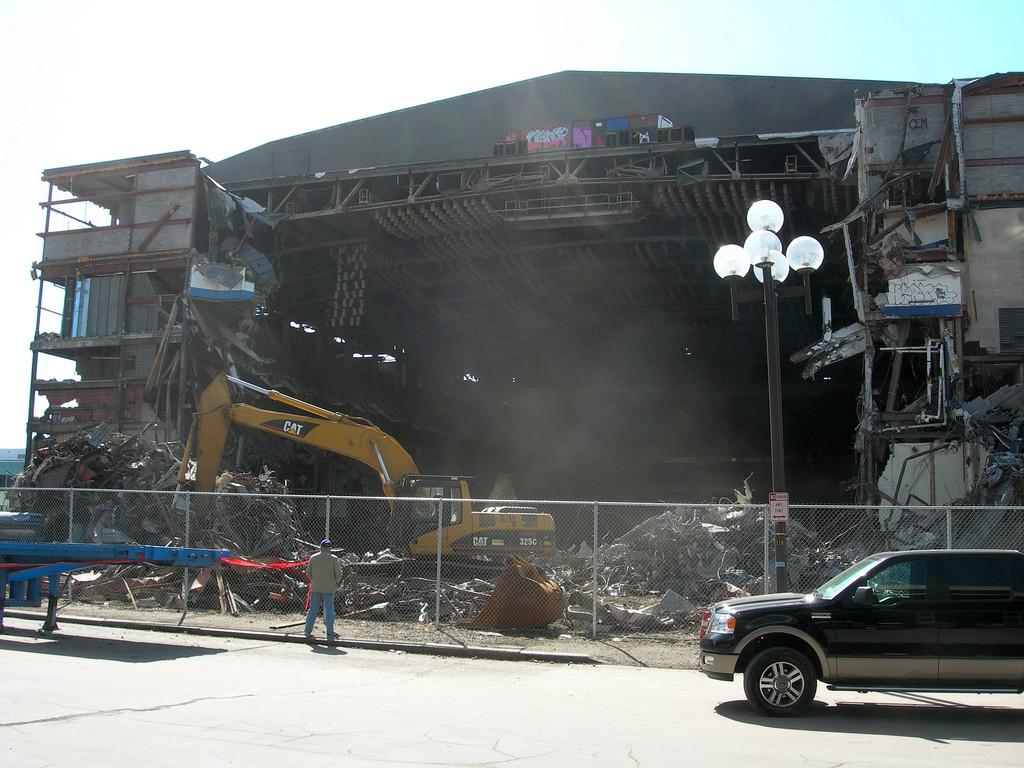What is the main subject in the center of the image? There is a car in the center of the image. What separates the image into two distinct areas? There is a boundary in the center of the image. What can be seen on the right side of the image? There is a pole on the right side of the image. What type of structure is being discovered in the image? There is no structure being discovered in the image; the facts provided only mention a car, a boundary, and a pole. 